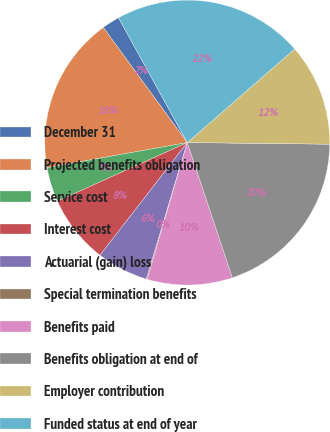Convert chart to OTSL. <chart><loc_0><loc_0><loc_500><loc_500><pie_chart><fcel>December 31<fcel>Projected benefits obligation<fcel>Service cost<fcel>Interest cost<fcel>Actuarial (gain) loss<fcel>Special termination benefits<fcel>Benefits paid<fcel>Benefits obligation at end of<fcel>Employer contribution<fcel>Funded status at end of year<nl><fcel>2.02%<fcel>17.78%<fcel>3.93%<fcel>7.76%<fcel>5.85%<fcel>0.1%<fcel>9.67%<fcel>19.69%<fcel>11.59%<fcel>21.61%<nl></chart> 